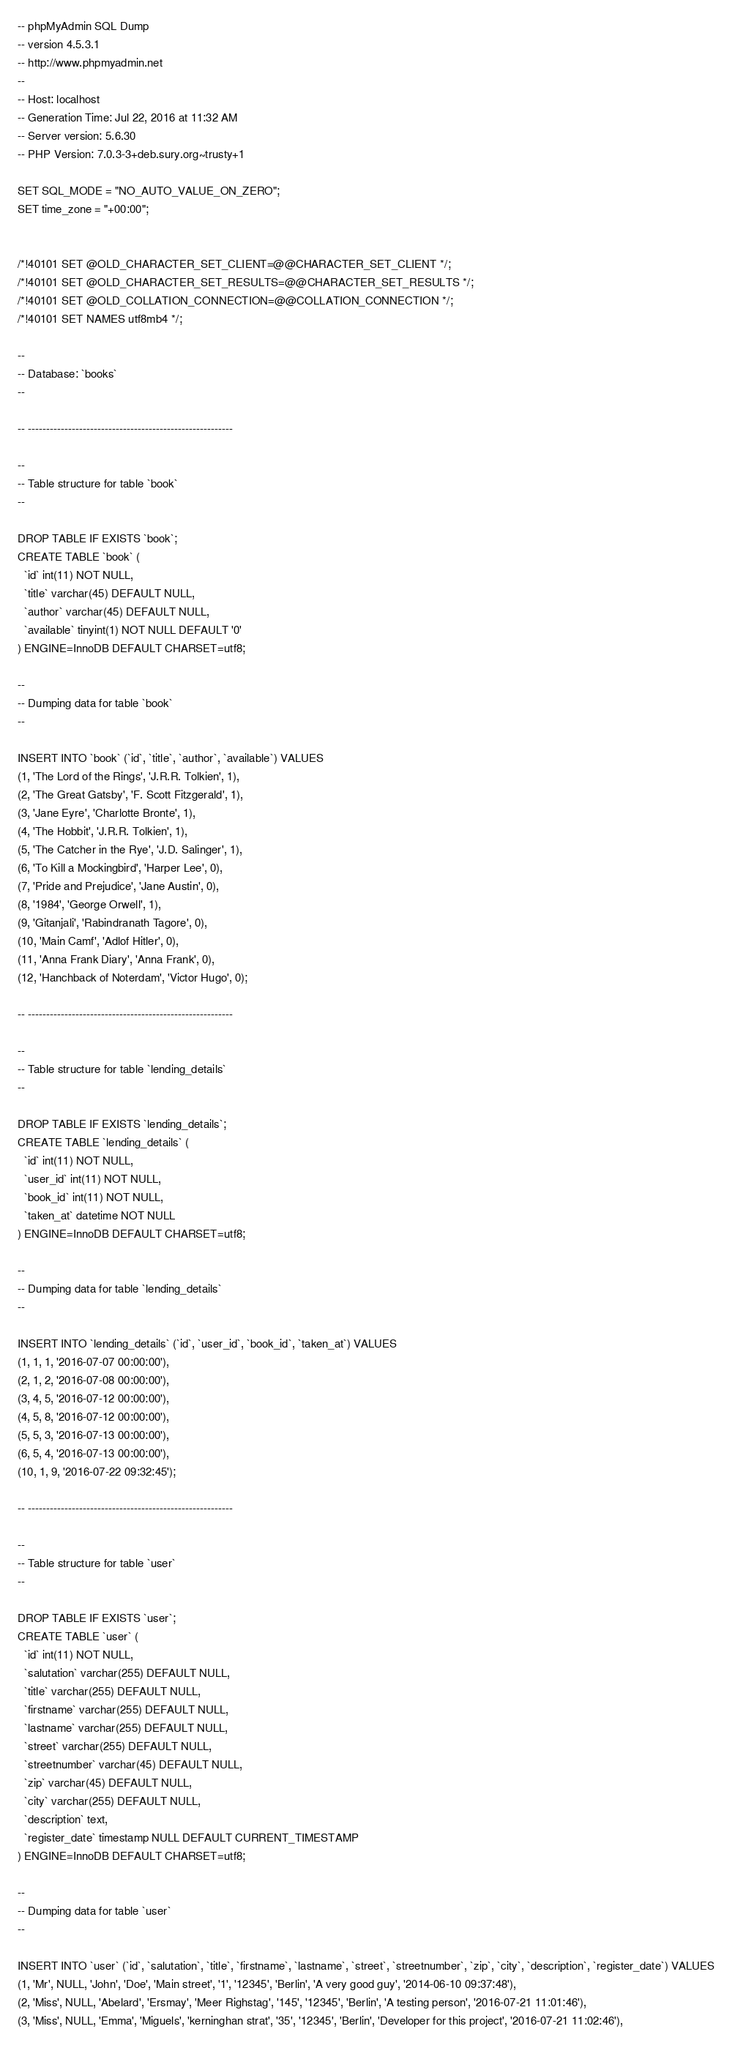<code> <loc_0><loc_0><loc_500><loc_500><_SQL_>-- phpMyAdmin SQL Dump
-- version 4.5.3.1
-- http://www.phpmyadmin.net
--
-- Host: localhost
-- Generation Time: Jul 22, 2016 at 11:32 AM
-- Server version: 5.6.30
-- PHP Version: 7.0.3-3+deb.sury.org~trusty+1

SET SQL_MODE = "NO_AUTO_VALUE_ON_ZERO";
SET time_zone = "+00:00";


/*!40101 SET @OLD_CHARACTER_SET_CLIENT=@@CHARACTER_SET_CLIENT */;
/*!40101 SET @OLD_CHARACTER_SET_RESULTS=@@CHARACTER_SET_RESULTS */;
/*!40101 SET @OLD_COLLATION_CONNECTION=@@COLLATION_CONNECTION */;
/*!40101 SET NAMES utf8mb4 */;

--
-- Database: `books`
--

-- --------------------------------------------------------

--
-- Table structure for table `book`
--

DROP TABLE IF EXISTS `book`;
CREATE TABLE `book` (
  `id` int(11) NOT NULL,
  `title` varchar(45) DEFAULT NULL,
  `author` varchar(45) DEFAULT NULL,
  `available` tinyint(1) NOT NULL DEFAULT '0'
) ENGINE=InnoDB DEFAULT CHARSET=utf8;

--
-- Dumping data for table `book`
--

INSERT INTO `book` (`id`, `title`, `author`, `available`) VALUES
(1, 'The Lord of the Rings', 'J.R.R. Tolkien', 1),
(2, 'The Great Gatsby', 'F. Scott Fitzgerald', 1),
(3, 'Jane Eyre', 'Charlotte Bronte', 1),
(4, 'The Hobbit', 'J.R.R. Tolkien', 1),
(5, 'The Catcher in the Rye', 'J.D. Salinger', 1),
(6, 'To Kill a Mockingbird', 'Harper Lee', 0),
(7, 'Pride and Prejudice', 'Jane Austin', 0),
(8, '1984', 'George Orwell', 1),
(9, 'Gitanjali', 'Rabindranath Tagore', 0),
(10, 'Main Camf', 'Adlof Hitler', 0),
(11, 'Anna Frank Diary', 'Anna Frank', 0),
(12, 'Hanchback of Noterdam', 'Victor Hugo', 0);

-- --------------------------------------------------------

--
-- Table structure for table `lending_details`
--

DROP TABLE IF EXISTS `lending_details`;
CREATE TABLE `lending_details` (
  `id` int(11) NOT NULL,
  `user_id` int(11) NOT NULL,
  `book_id` int(11) NOT NULL,
  `taken_at` datetime NOT NULL
) ENGINE=InnoDB DEFAULT CHARSET=utf8;

--
-- Dumping data for table `lending_details`
--

INSERT INTO `lending_details` (`id`, `user_id`, `book_id`, `taken_at`) VALUES
(1, 1, 1, '2016-07-07 00:00:00'),
(2, 1, 2, '2016-07-08 00:00:00'),
(3, 4, 5, '2016-07-12 00:00:00'),
(4, 5, 8, '2016-07-12 00:00:00'),
(5, 5, 3, '2016-07-13 00:00:00'),
(6, 5, 4, '2016-07-13 00:00:00'),
(10, 1, 9, '2016-07-22 09:32:45');

-- --------------------------------------------------------

--
-- Table structure for table `user`
--

DROP TABLE IF EXISTS `user`;
CREATE TABLE `user` (
  `id` int(11) NOT NULL,
  `salutation` varchar(255) DEFAULT NULL,
  `title` varchar(255) DEFAULT NULL,
  `firstname` varchar(255) DEFAULT NULL,
  `lastname` varchar(255) DEFAULT NULL,
  `street` varchar(255) DEFAULT NULL,
  `streetnumber` varchar(45) DEFAULT NULL,
  `zip` varchar(45) DEFAULT NULL,
  `city` varchar(255) DEFAULT NULL,
  `description` text,
  `register_date` timestamp NULL DEFAULT CURRENT_TIMESTAMP
) ENGINE=InnoDB DEFAULT CHARSET=utf8;

--
-- Dumping data for table `user`
--

INSERT INTO `user` (`id`, `salutation`, `title`, `firstname`, `lastname`, `street`, `streetnumber`, `zip`, `city`, `description`, `register_date`) VALUES
(1, 'Mr', NULL, 'John', 'Doe', 'Main street', '1', '12345', 'Berlin', 'A very good guy', '2014-06-10 09:37:48'),
(2, 'Miss', NULL, 'Abelard', 'Ersmay', 'Meer Righstag', '145', '12345', 'Berlin', 'A testing person', '2016-07-21 11:01:46'),
(3, 'Miss', NULL, 'Emma', 'Miguels', 'kerninghan strat', '35', '12345', 'Berlin', 'Developer for this project', '2016-07-21 11:02:46'),</code> 